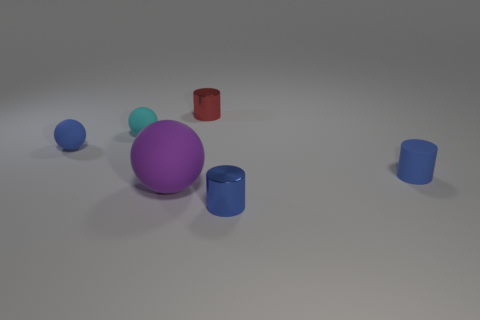How many other objects are there of the same color as the rubber cylinder?
Provide a succinct answer. 2. What number of things are in front of the tiny cyan matte ball and to the left of the purple matte ball?
Make the answer very short. 1. Is there any other thing that is the same size as the purple matte object?
Provide a short and direct response. No. Are there more big purple rubber balls in front of the tiny red shiny thing than small red cylinders on the left side of the blue sphere?
Offer a terse response. Yes. What material is the small cylinder that is behind the blue sphere?
Your answer should be compact. Metal. Do the red metal object and the blue matte thing behind the blue matte cylinder have the same shape?
Offer a terse response. No. How many matte objects are on the right side of the blue matte object that is to the right of the matte sphere that is on the left side of the small cyan rubber sphere?
Provide a succinct answer. 0. The other tiny object that is the same shape as the cyan object is what color?
Your answer should be very brief. Blue. How many balls are large blue shiny things or small blue objects?
Keep it short and to the point. 1. What is the shape of the large rubber object?
Give a very brief answer. Sphere. 